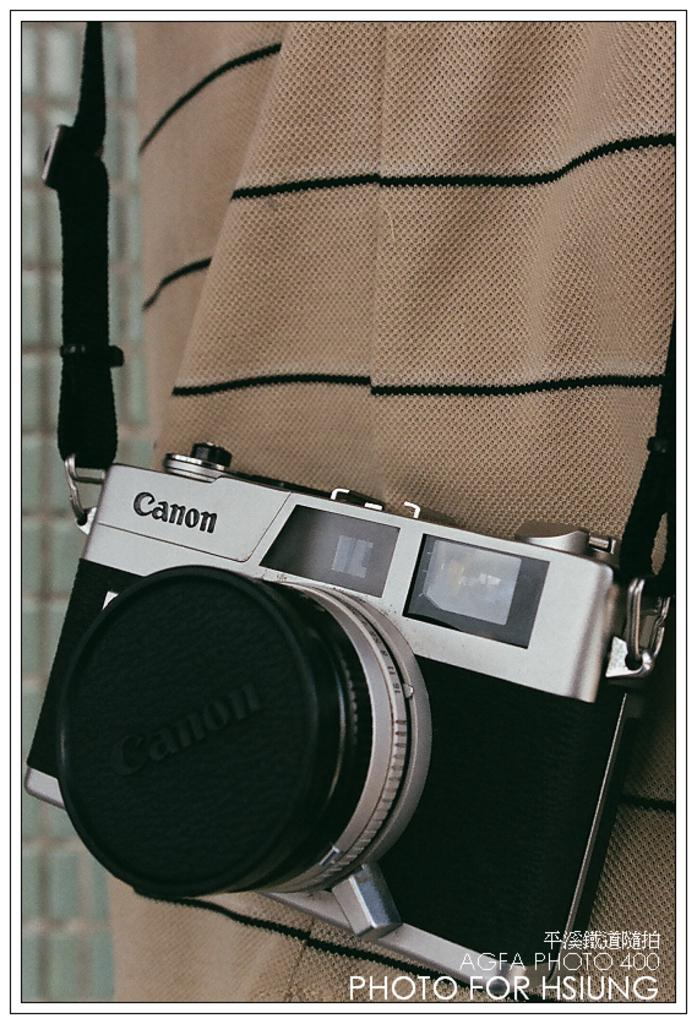What is the main object in the center of the image? There is a camera in the center of the image. Who is associated with the camera in the image? A man is behind the camera. How is the camera positioned in relation to the man? The camera appears to be hanging from the man's neck. What type of vase is being used as a prop in the image? There is no vase present in the image. How many rings can be seen on the man's fingers in the image? There is no mention of rings on the man's fingers in the image. 